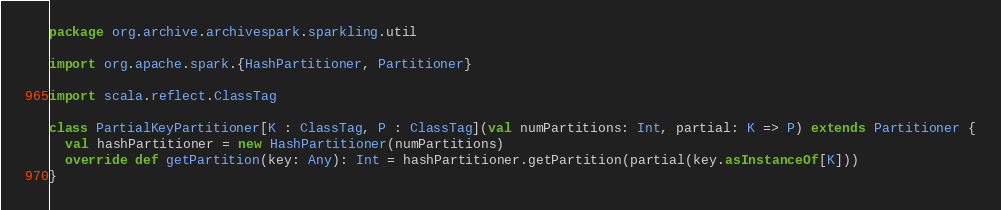Convert code to text. <code><loc_0><loc_0><loc_500><loc_500><_Scala_>package org.archive.archivespark.sparkling.util

import org.apache.spark.{HashPartitioner, Partitioner}

import scala.reflect.ClassTag

class PartialKeyPartitioner[K : ClassTag, P : ClassTag](val numPartitions: Int, partial: K => P) extends Partitioner {
  val hashPartitioner = new HashPartitioner(numPartitions)
  override def getPartition(key: Any): Int = hashPartitioner.getPartition(partial(key.asInstanceOf[K]))
}</code> 